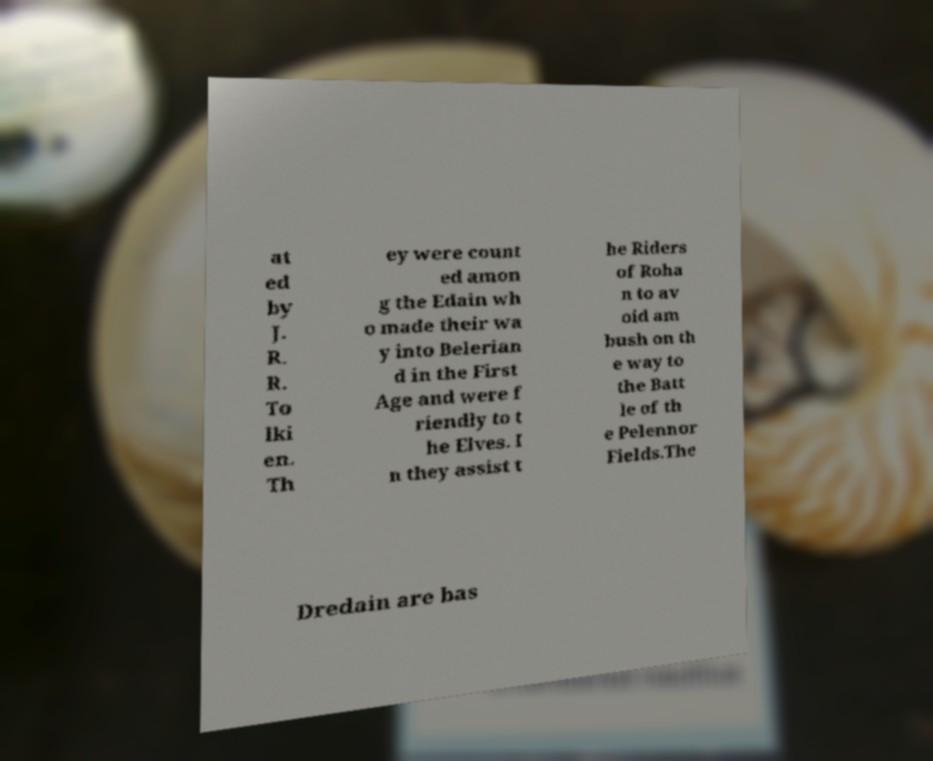Could you assist in decoding the text presented in this image and type it out clearly? at ed by J. R. R. To lki en. Th ey were count ed amon g the Edain wh o made their wa y into Belerian d in the First Age and were f riendly to t he Elves. I n they assist t he Riders of Roha n to av oid am bush on th e way to the Batt le of th e Pelennor Fields.The Dredain are bas 